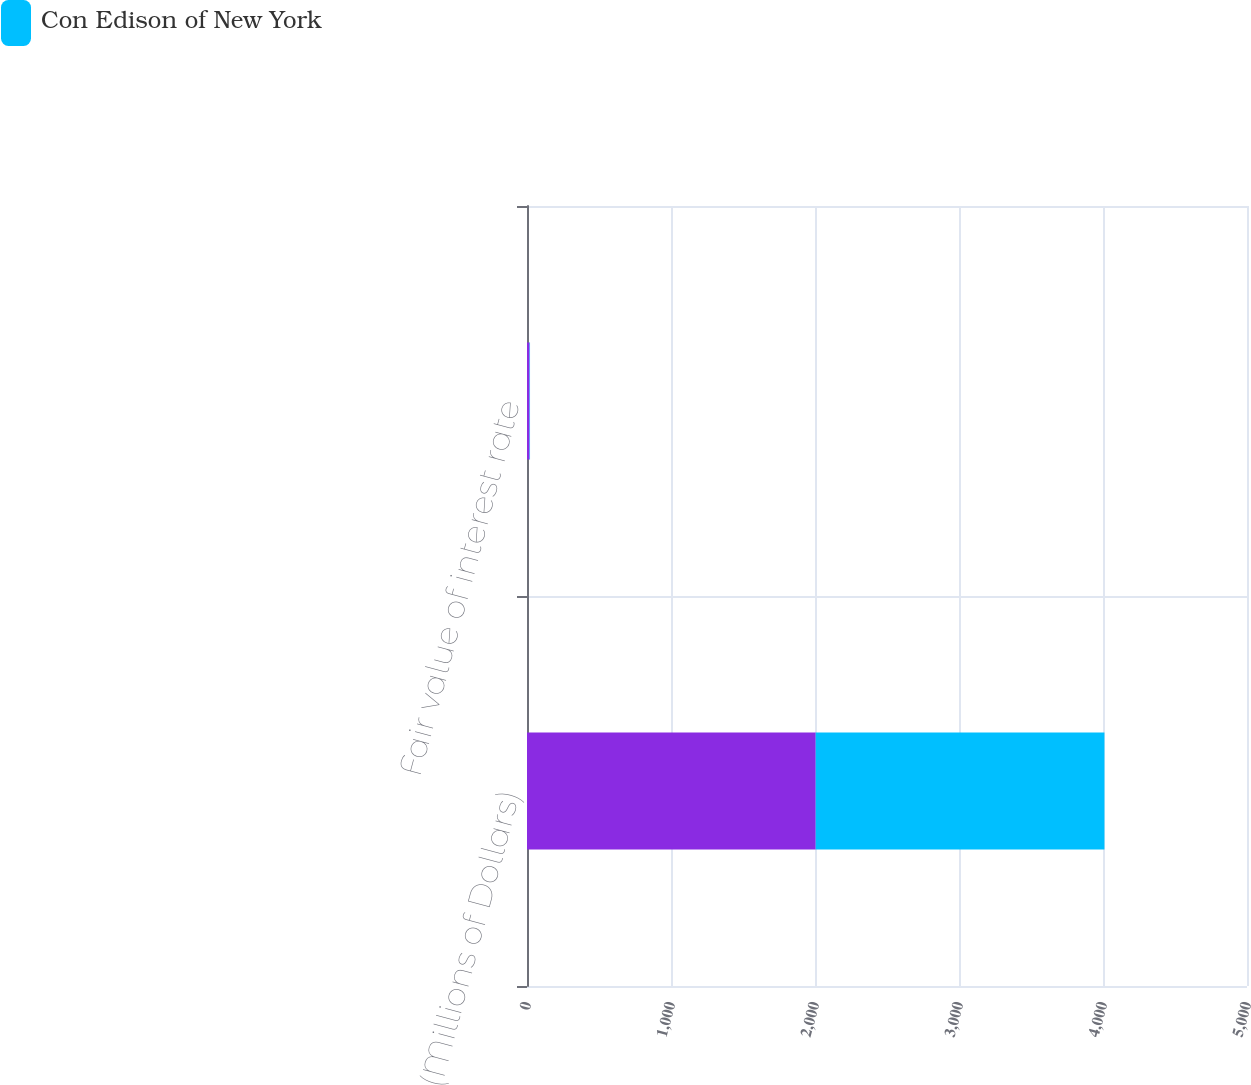Convert chart. <chart><loc_0><loc_0><loc_500><loc_500><stacked_bar_chart><ecel><fcel>(Millions of Dollars)<fcel>Fair value of interest rate<nl><fcel>nan<fcel>2005<fcel>18<nl><fcel>Con Edison of New York<fcel>2005<fcel>3<nl></chart> 